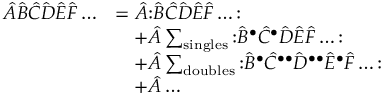<formula> <loc_0><loc_0><loc_500><loc_500>{ \begin{array} { r l } { { \hat { A } } { \hat { B } } { \hat { C } } { \hat { D } } { \hat { E } } { \hat { F } } \dots } & { = { \hat { A } } { \colon } { \hat { B } } { \hat { C } } { \hat { D } } { \hat { E } } { \hat { F } } \dots { \colon } } \\ & { \quad + { \hat { A } } \sum _ { \sin g l e s } { \colon } { \hat { B } } ^ { \bullet } { \hat { C } } ^ { \bullet } { \hat { D } } { \hat { E } } { \hat { F } } \dots { \colon } } \\ & { \quad + { \hat { A } } \sum _ { d o u b l e s } { \colon } { \hat { B } } ^ { \bullet } { \hat { C } } ^ { \bullet \bullet } { \hat { D } } ^ { \bullet \bullet } { \hat { E } } ^ { \bullet } { \hat { F } } \dots { \colon } } \\ & { \quad + { \hat { A } } \dots } \end{array} }</formula> 